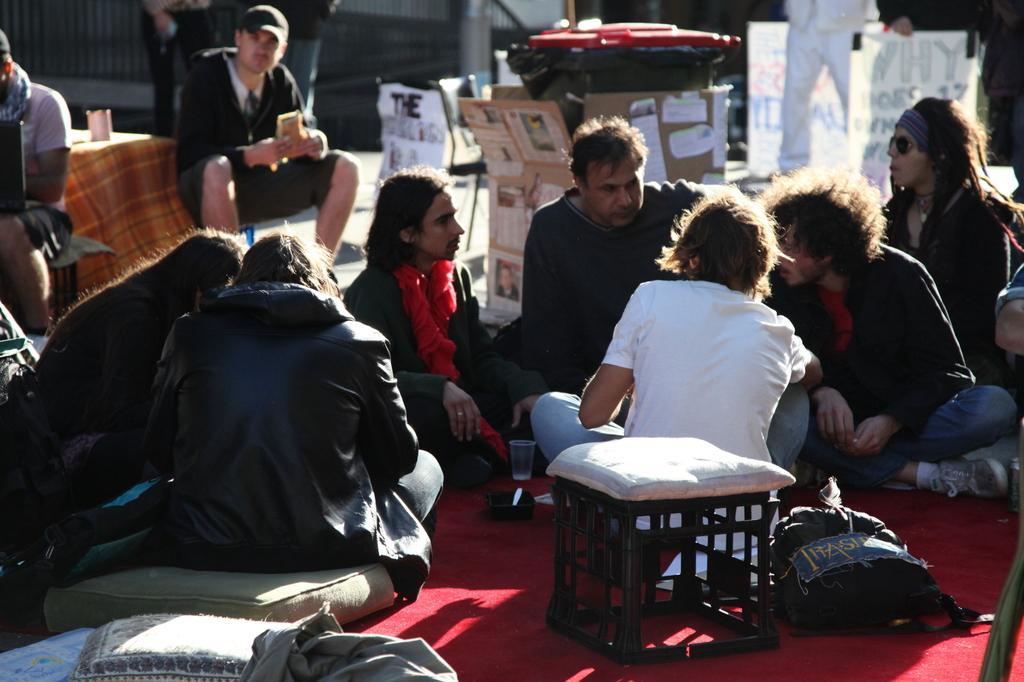How would you summarize this image in a sentence or two? In this image there are few persons sitting on the floor having a stool, bag, pillows are on it. A person is sitting on the stool. He is wearing a cap. Beside him there is a table having a glass on it. Middle of the image there is a dustbin which is covered with the cardboards. There are few boards on the floor. Few persons are standing on the floor. 